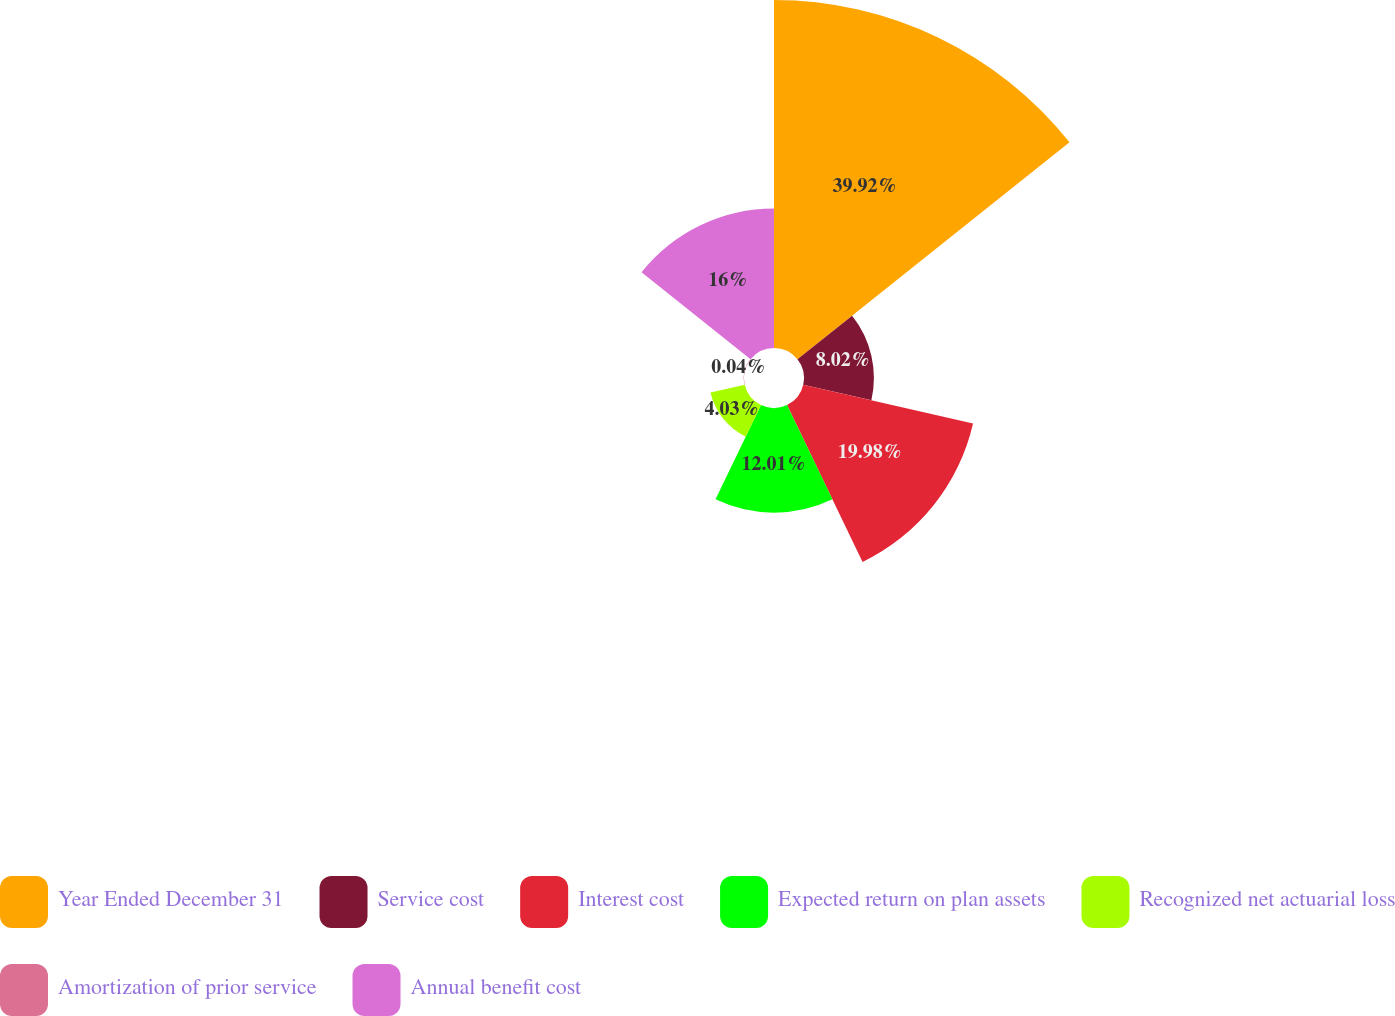Convert chart. <chart><loc_0><loc_0><loc_500><loc_500><pie_chart><fcel>Year Ended December 31<fcel>Service cost<fcel>Interest cost<fcel>Expected return on plan assets<fcel>Recognized net actuarial loss<fcel>Amortization of prior service<fcel>Annual benefit cost<nl><fcel>39.93%<fcel>8.02%<fcel>19.98%<fcel>12.01%<fcel>4.03%<fcel>0.04%<fcel>16.0%<nl></chart> 